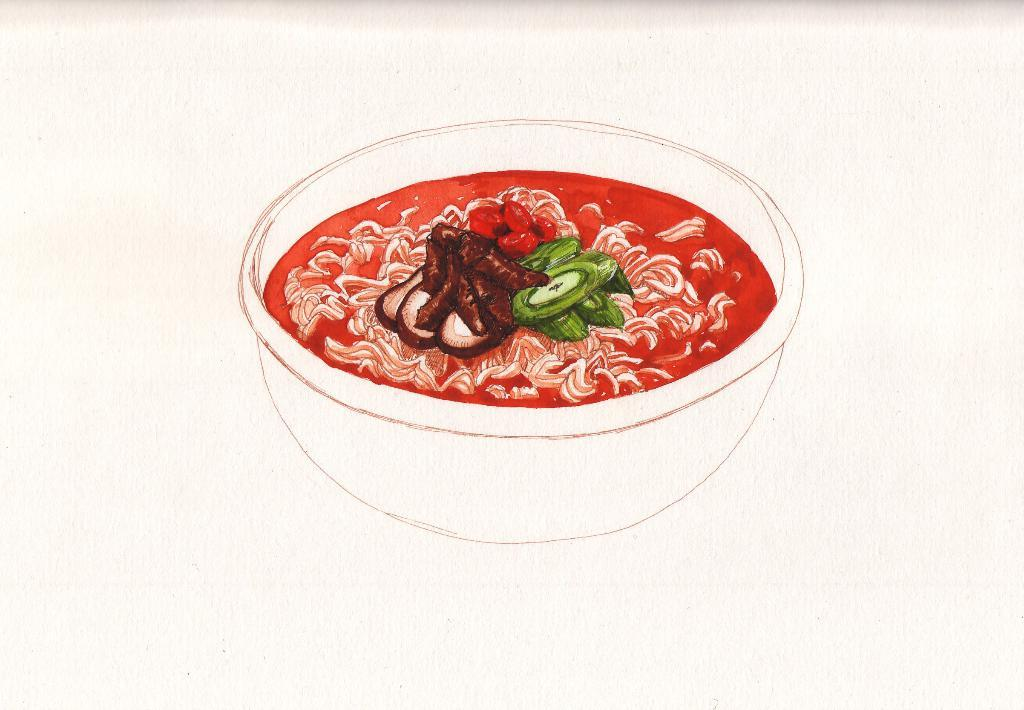What is the main subject of the image? There is a painting in the image. What is depicted in the painting? The painting contains a bowl. What is inside the bowl in the painting? The bowl has food in it. What is the color of the food in the bowl? The food is red in color. What direction is the hill facing in the image? There is no hill present in the image; it is a painting of a bowl with red food in it. 